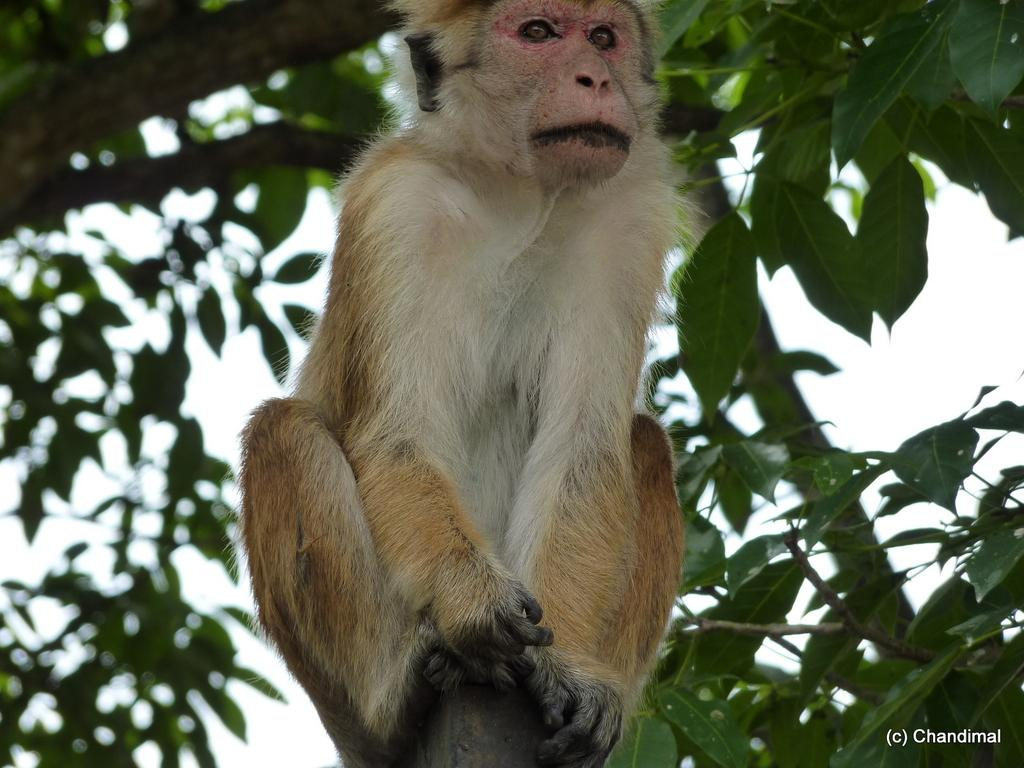What type of animal is in the image? There is a monkey in the image. What is the monkey doing in the image? The monkey is sitting on an object. What can be seen in the background of the image? There are trees and the sky visible in the background of the image. What type of coat is the monkey wearing in the image? There is no coat visible on the monkey in the image. Can you tell me how many lakes are present in the image? There are no lakes present in the image. --- 